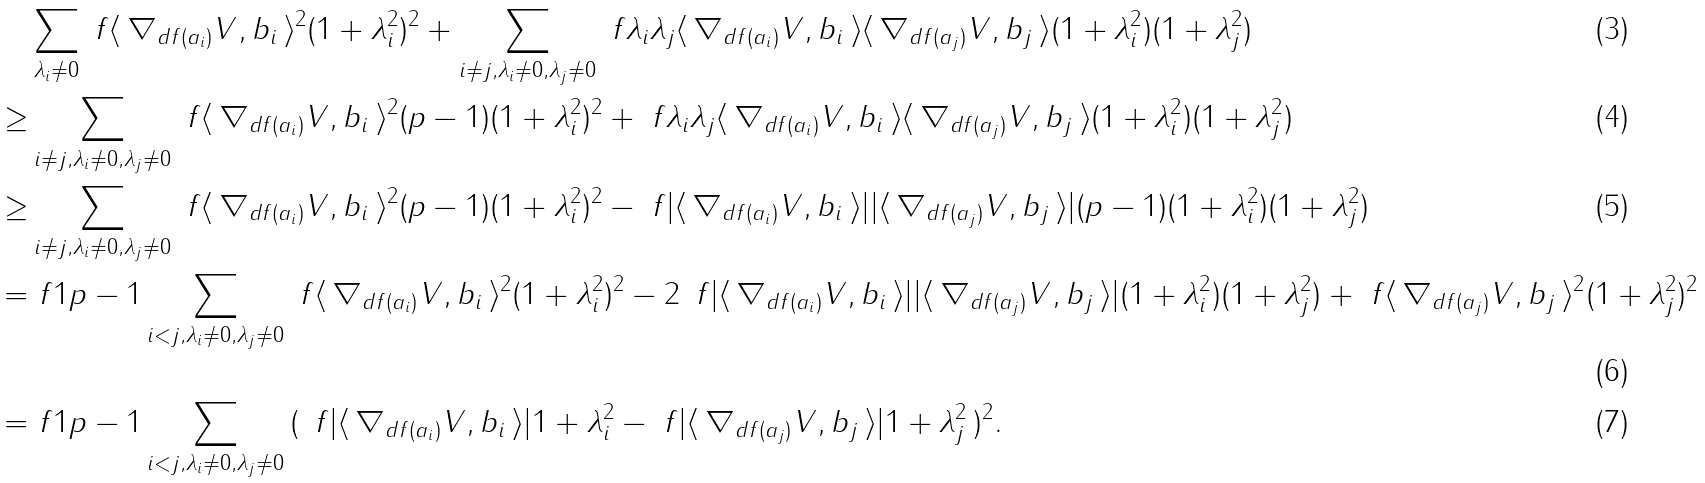Convert formula to latex. <formula><loc_0><loc_0><loc_500><loc_500>& \sum _ { \lambda _ { i } \neq 0 } \ f { \langle \, \nabla _ { d f ( a _ { i } ) } V , b _ { i } \, \rangle ^ { 2 } } { ( 1 + \lambda _ { i } ^ { 2 } ) ^ { 2 } } + \sum _ { i \neq j , \lambda _ { i } \neq 0 , \lambda _ { j } \neq 0 } \ f { \lambda _ { i } \lambda _ { j } \langle \, \nabla _ { d f ( a _ { i } ) } V , b _ { i } \, \rangle \langle \, \nabla _ { d f ( a _ { j } ) } V , b _ { j } \, \rangle } { ( 1 + \lambda _ { i } ^ { 2 } ) ( 1 + \lambda _ { j } ^ { 2 } ) } \\ \geq & \sum _ { i \neq j , \lambda _ { i } \neq 0 , \lambda _ { j } \neq 0 } \ f { \langle \, \nabla _ { d f ( a _ { i } ) } V , b _ { i } \, \rangle ^ { 2 } } { ( p - 1 ) ( 1 + \lambda _ { i } ^ { 2 } ) ^ { 2 } } + \ f { \lambda _ { i } \lambda _ { j } \langle \, \nabla _ { d f ( a _ { i } ) } V , b _ { i } \, \rangle \langle \, \nabla _ { d f ( a _ { j } ) } V , b _ { j } \, \rangle } { ( 1 + \lambda _ { i } ^ { 2 } ) ( 1 + \lambda _ { j } ^ { 2 } ) } \\ \geq & \sum _ { i \neq j , \lambda _ { i } \neq 0 , \lambda _ { j } \neq 0 } \ f { \langle \, \nabla _ { d f ( a _ { i } ) } V , b _ { i } \, \rangle ^ { 2 } } { ( p - 1 ) ( 1 + \lambda _ { i } ^ { 2 } ) ^ { 2 } } - \ f { | \langle \, \nabla _ { d f ( a _ { i } ) } V , b _ { i } \, \rangle | | \langle \, \nabla _ { d f ( a _ { j } ) } V , b _ { j } \, \rangle | } { ( p - 1 ) ( 1 + \lambda _ { i } ^ { 2 } ) ( 1 + \lambda _ { j } ^ { 2 } ) } \\ = & \ f { 1 } { p - 1 } \sum _ { i < j , \lambda _ { i } \neq 0 , \lambda _ { j } \neq 0 } \ f { \langle \, \nabla _ { d f ( a _ { i } ) } V , b _ { i } \, \rangle ^ { 2 } } { ( 1 + \lambda _ { i } ^ { 2 } ) ^ { 2 } } - 2 \, \ f { | \langle \, \nabla _ { d f ( a _ { i } ) } V , b _ { i } \, \rangle | | \langle \, \nabla _ { d f ( a _ { j } ) } V , b _ { j } \, \rangle | } { ( 1 + \lambda _ { i } ^ { 2 } ) ( 1 + \lambda _ { j } ^ { 2 } ) } + \ f { \langle \, \nabla _ { d f ( a _ { j } ) } V , b _ { j } \, \rangle ^ { 2 } } { ( 1 + \lambda _ { j } ^ { 2 } ) ^ { 2 } } \\ = & \ f { 1 } { p - 1 } \sum _ { i < j , \lambda _ { i } \neq 0 , \lambda _ { j } \neq 0 } \, ( \, \ f { | \langle \, \nabla _ { d f ( a _ { i } ) } V , b _ { i } \, \rangle | } { 1 + \lambda _ { i } ^ { 2 } } - \ f { | \langle \, \nabla _ { d f ( a _ { j } ) } V , b _ { j } \, \rangle | } { 1 + \lambda _ { j } ^ { 2 } } \, ) ^ { 2 } .</formula> 